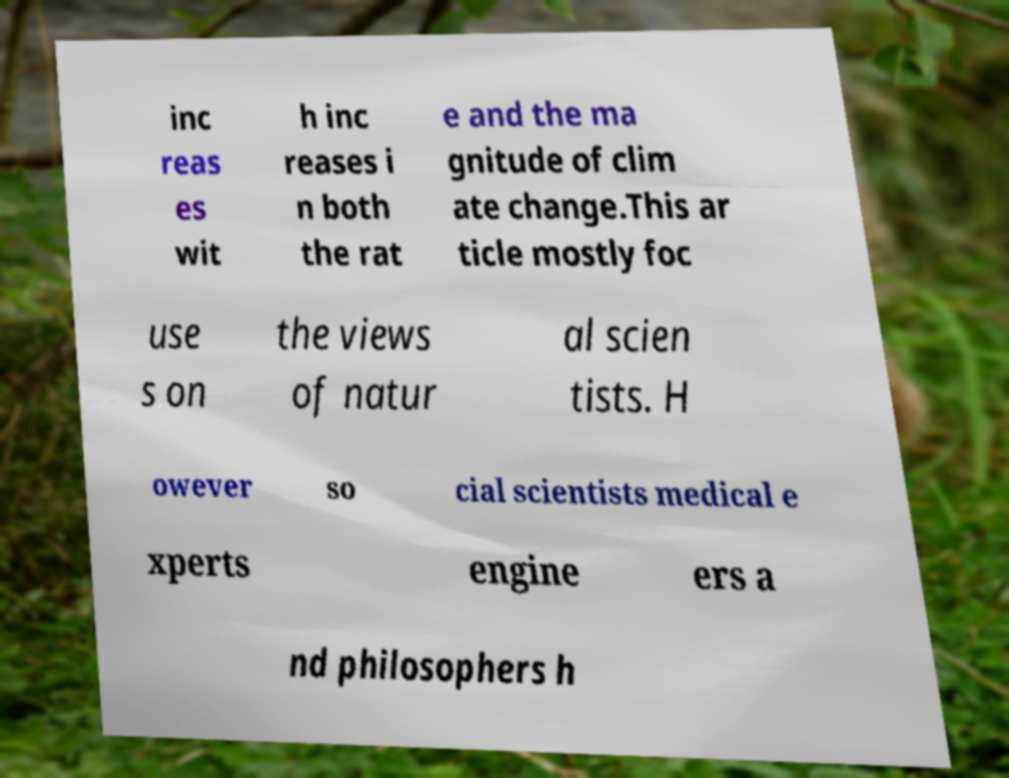Can you read and provide the text displayed in the image?This photo seems to have some interesting text. Can you extract and type it out for me? inc reas es wit h inc reases i n both the rat e and the ma gnitude of clim ate change.This ar ticle mostly foc use s on the views of natur al scien tists. H owever so cial scientists medical e xperts engine ers a nd philosophers h 